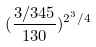<formula> <loc_0><loc_0><loc_500><loc_500>( \frac { 3 / 3 4 5 } { 1 3 0 } ) ^ { 2 ^ { 3 } / 4 }</formula> 